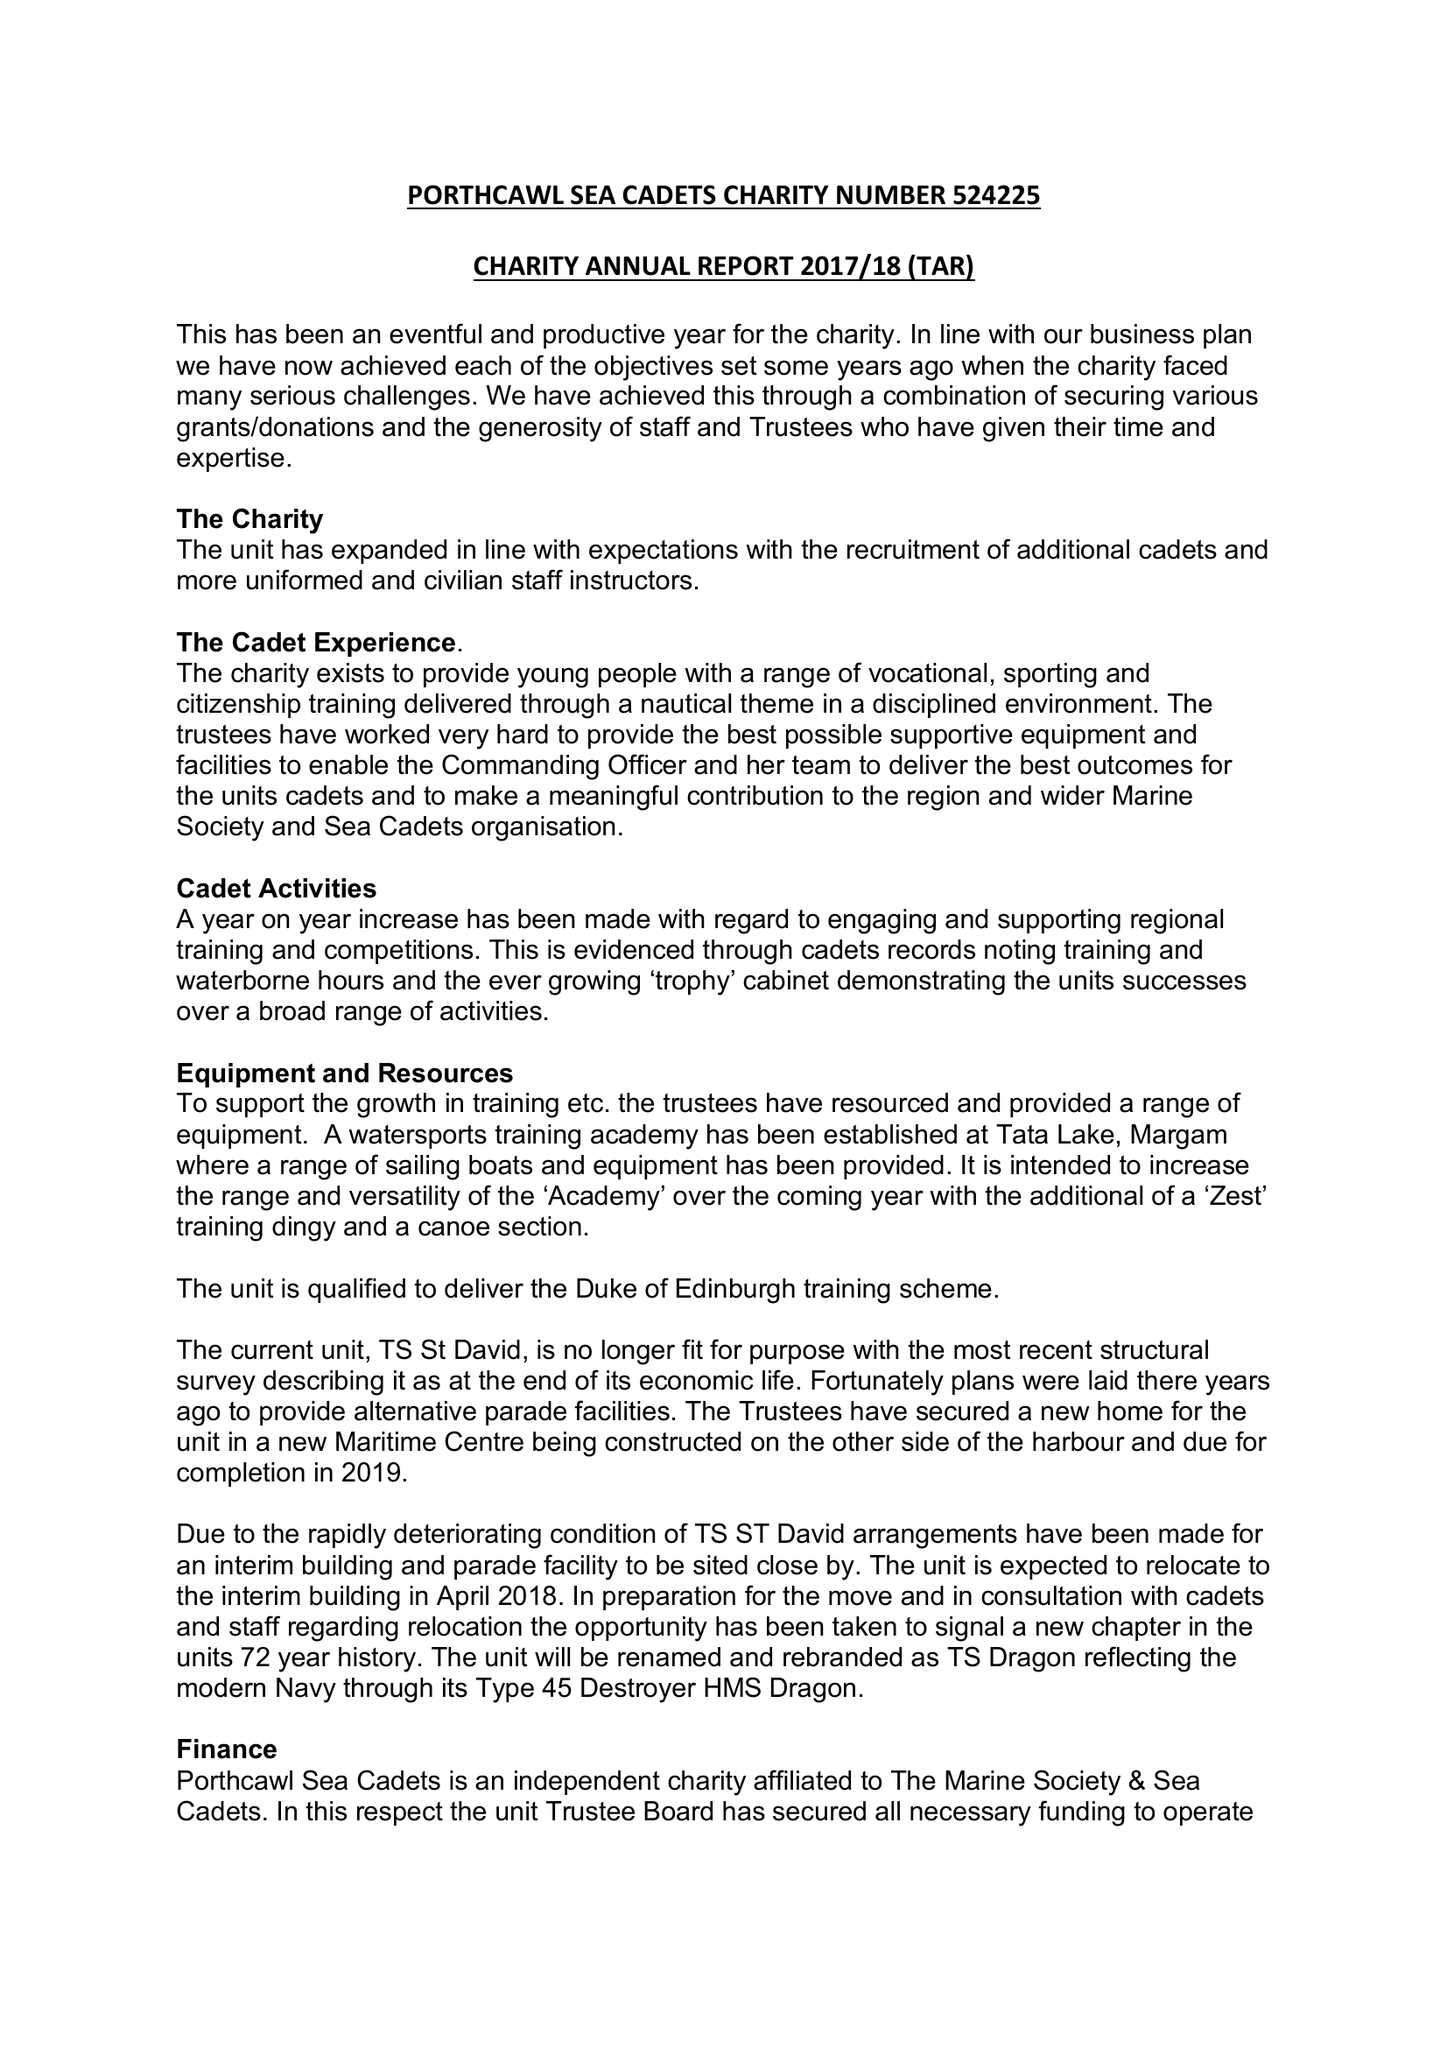What is the value for the address__postcode?
Answer the question using a single word or phrase. CF36 3UU 